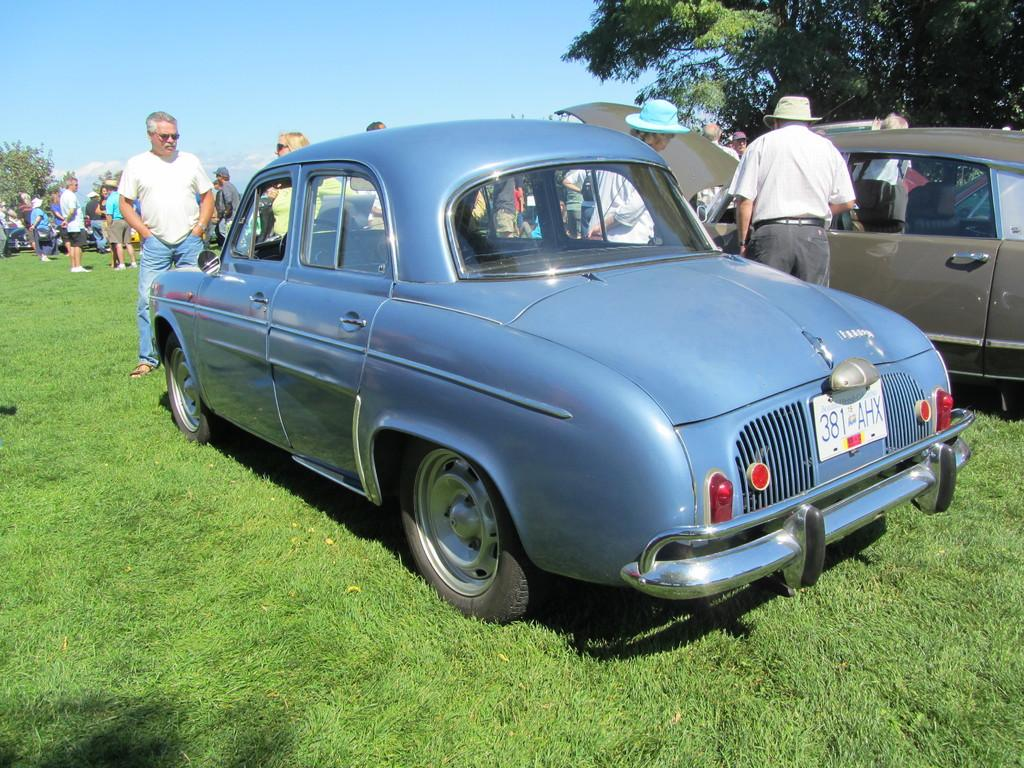What type of vehicles can be seen in the image? There are cars in the image. Who or what else is present in the image? There are people in the image. What type of vegetation is visible at the bottom of the image? There is grass at the bottom of the image. What can be seen in the background of the image? There are trees and the sky visible in the background of the image. What type of pies are being served to the people in the image? There are no pies present in the image; it features cars, people, grass, trees, and the sky. How do the people in the image express their disgust towards the snow? There is no snow or expression of disgust present in the image. 